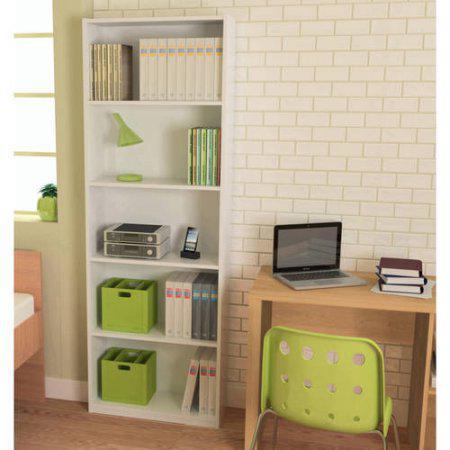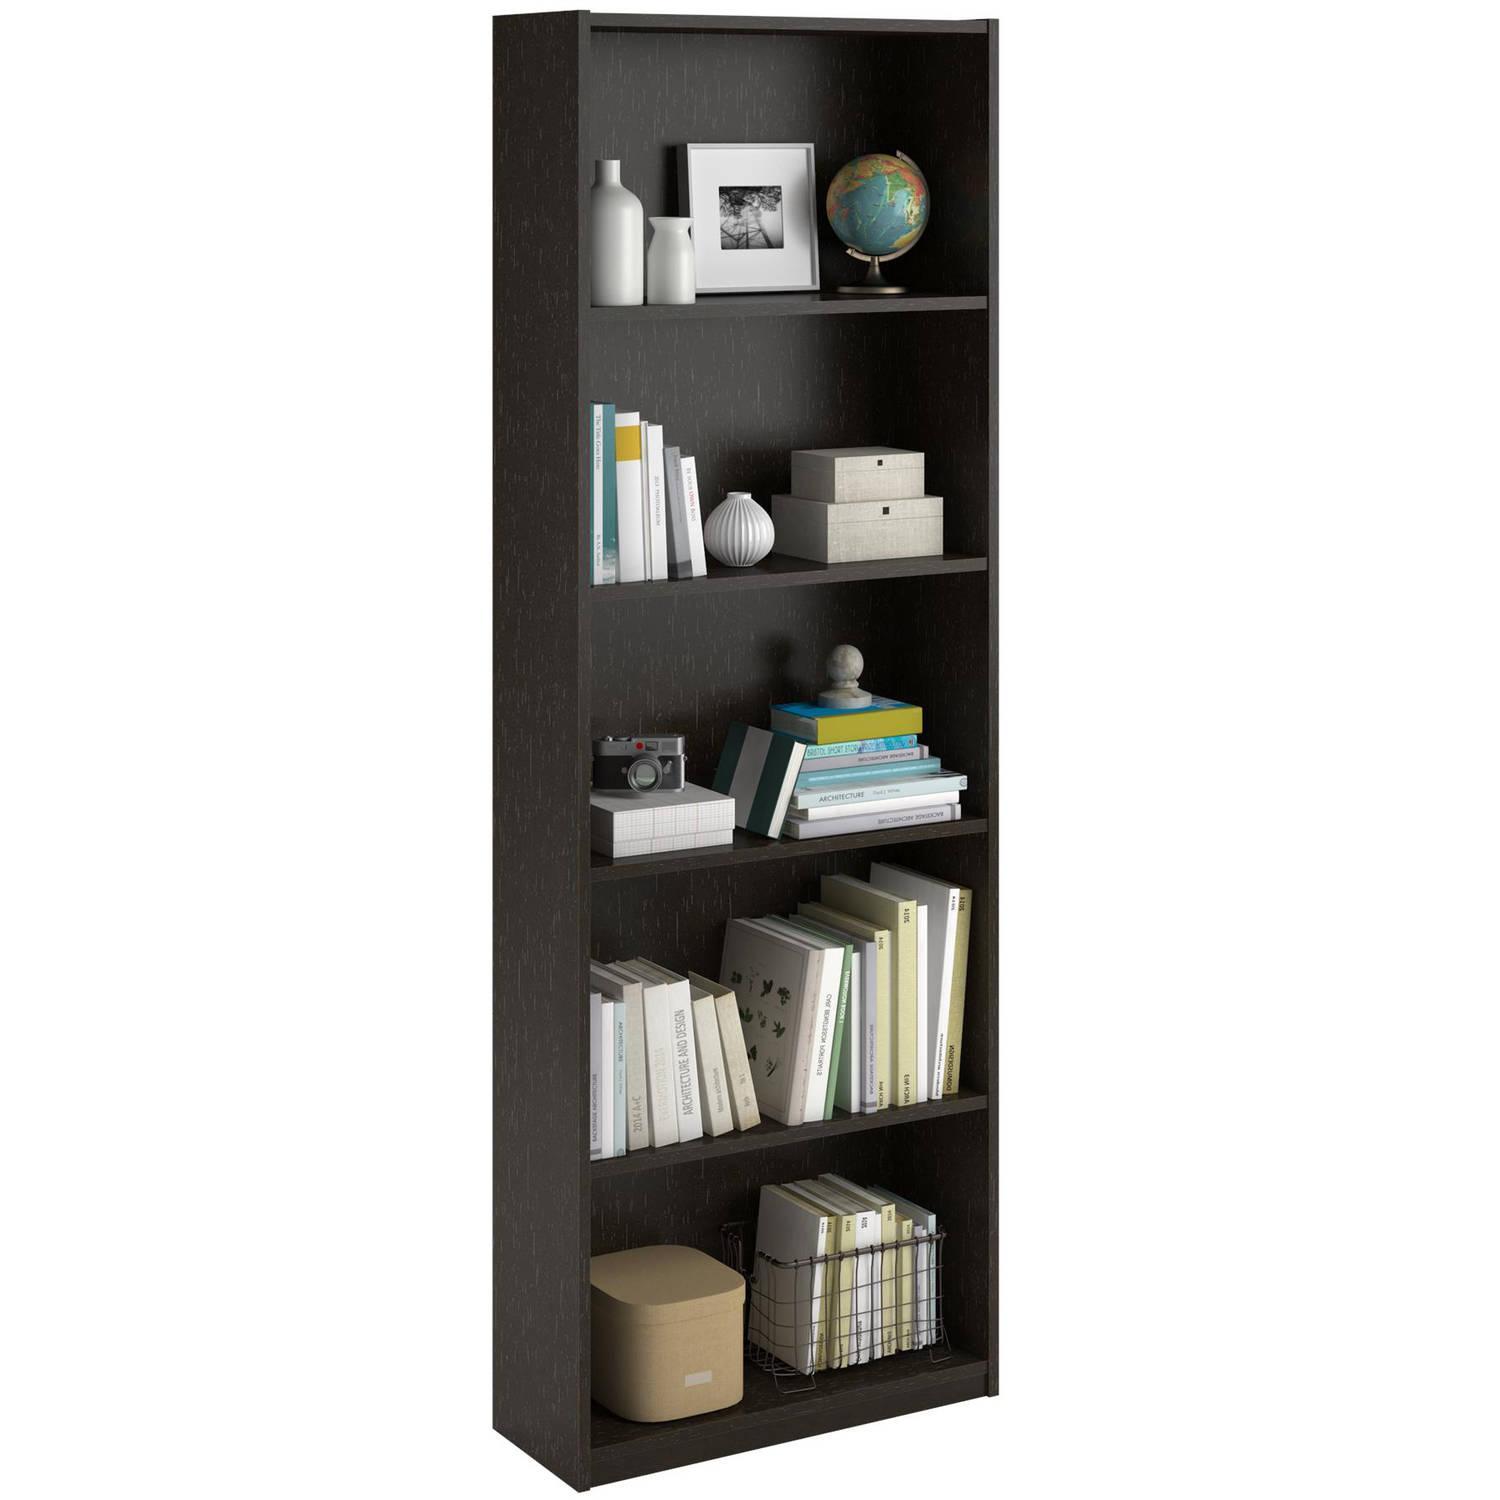The first image is the image on the left, the second image is the image on the right. Evaluate the accuracy of this statement regarding the images: "One of the bookshelves is white.". Is it true? Answer yes or no. Yes. 